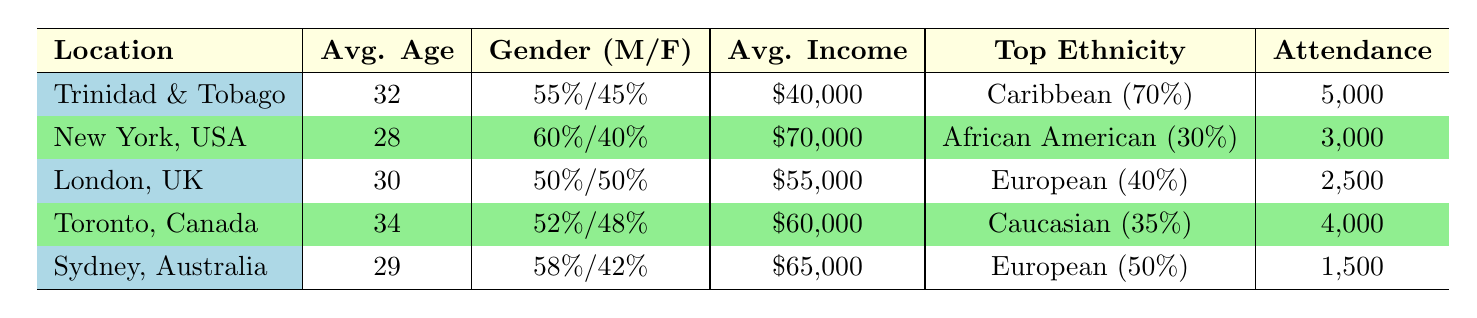What is the average age of the audience in Trinidad and Tobago? The average age for the audience in Trinidad and Tobago is specified directly in the table under the "Avg. Age" column. It states 32.
Answer: 32 Which concert location has the highest attendance? To determine the highest attendance, we need to compare the attendance figures for each location. Trinidad and Tobago has 5,000, New York has 3,000, London has 2,500, Toronto has 4,000, and Sydney has 1,500. The highest value is 5,000 from Trinidad and Tobago.
Answer: Trinidad and Tobago What percentage of the audience in New York is Hispanic? The table provides the gender distribution and ethnicity for New York. It indicates that the Hispanic audience constitutes 25%.
Answer: 25% Is the audience in London evenly split between genders? The gender distribution in London shows 50% male and 50% female, which is an even split. Therefore, the statement is true.
Answer: Yes What is the average income of audience members in Toronto and Sydney combined? We take the average incomes from Toronto ($60,000) and Sydney ($65,000), sum them up (60,000 + 65,000 = 125,000), and then divide by 2 to find the average (125,000 / 2 = 62,500).
Answer: $62,500 How many more Caribbean audience members are there in Trinidad and Tobago than in Toronto? From the table, Trinidad and Tobago has 70% Caribbean audience members, and Toronto has 15%. To find the difference, we look at their respective attendance (5,000 for Trinidad and 4,000 for Toronto). Thus, Caribbean audience members are 3,500 in Trinidad (70% of 5,000) and 600 in Toronto (15% of 4,000). The difference is 3,500 - 600 = 2,900.
Answer: 2,900 Which location has the highest percentage of Asian audience members? The percentage of Asian audience members listed is 15% for Trinidad and Tobago, 20% for London, 30% for Toronto, and 25% for Sydney. The highest is 30% in Toronto.
Answer: Toronto Does the average age of concert-goers in New York differ from that in Sydney? The average age in New York is 28, while in Sydney it is 29. The ages differ by 29 - 28 = 1 year, thus indicating they are not the same.
Answer: Yes, they differ by 1 year How many total attendees were recorded across all listed concert locations? We sum the attendance figures for all locations: 5,000 (Trinidad) + 3,000 (New York) + 2,500 (London) + 4,000 (Toronto) + 1,500 (Sydney) = 16,000 total attendees.
Answer: 16,000 